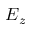<formula> <loc_0><loc_0><loc_500><loc_500>E _ { z }</formula> 